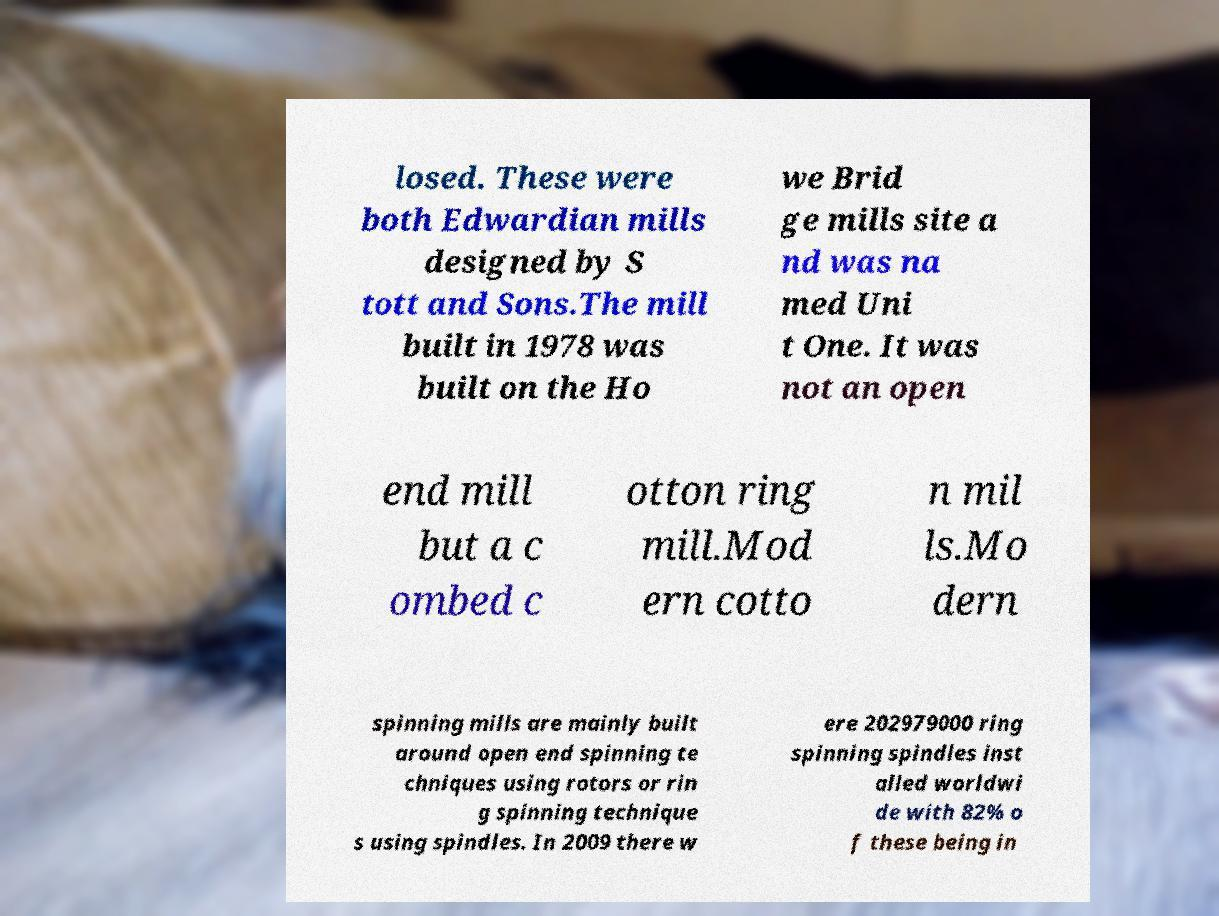I need the written content from this picture converted into text. Can you do that? losed. These were both Edwardian mills designed by S tott and Sons.The mill built in 1978 was built on the Ho we Brid ge mills site a nd was na med Uni t One. It was not an open end mill but a c ombed c otton ring mill.Mod ern cotto n mil ls.Mo dern spinning mills are mainly built around open end spinning te chniques using rotors or rin g spinning technique s using spindles. In 2009 there w ere 202979000 ring spinning spindles inst alled worldwi de with 82% o f these being in 